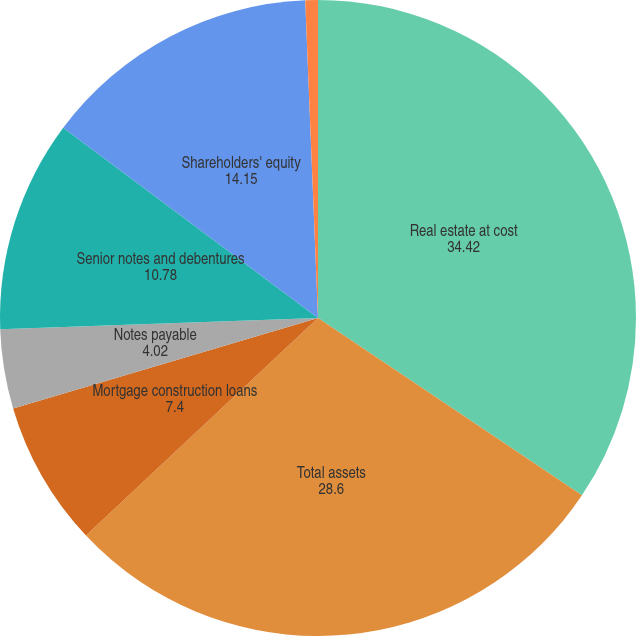<chart> <loc_0><loc_0><loc_500><loc_500><pie_chart><fcel>Real estate at cost<fcel>Total assets<fcel>Mortgage construction loans<fcel>Notes payable<fcel>Senior notes and debentures<fcel>Shareholders' equity<fcel>Number of common shares<nl><fcel>34.42%<fcel>28.6%<fcel>7.4%<fcel>4.02%<fcel>10.78%<fcel>14.15%<fcel>0.64%<nl></chart> 